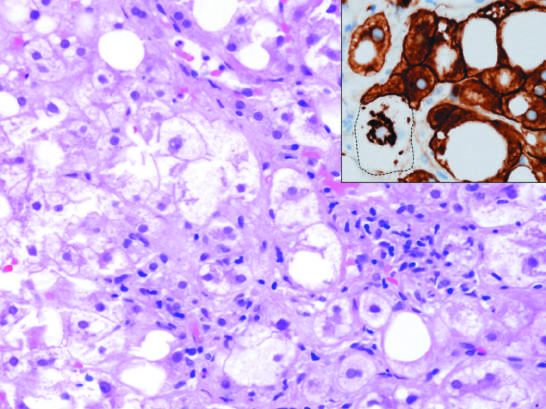does the inset stained for keratins 8 and 18 show a ballooned cell (dotted line) in which keratins have been ubiquitinylated and have collapsed into an immunoreactive mallory-denk body, leaving the cytoplasm empty?
Answer the question using a single word or phrase. Yes 